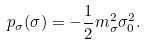Convert formula to latex. <formula><loc_0><loc_0><loc_500><loc_500>p _ { \sigma } ( \sigma ) = - \frac { 1 } { 2 } m _ { \sigma } ^ { 2 } \sigma _ { 0 } ^ { 2 } .</formula> 